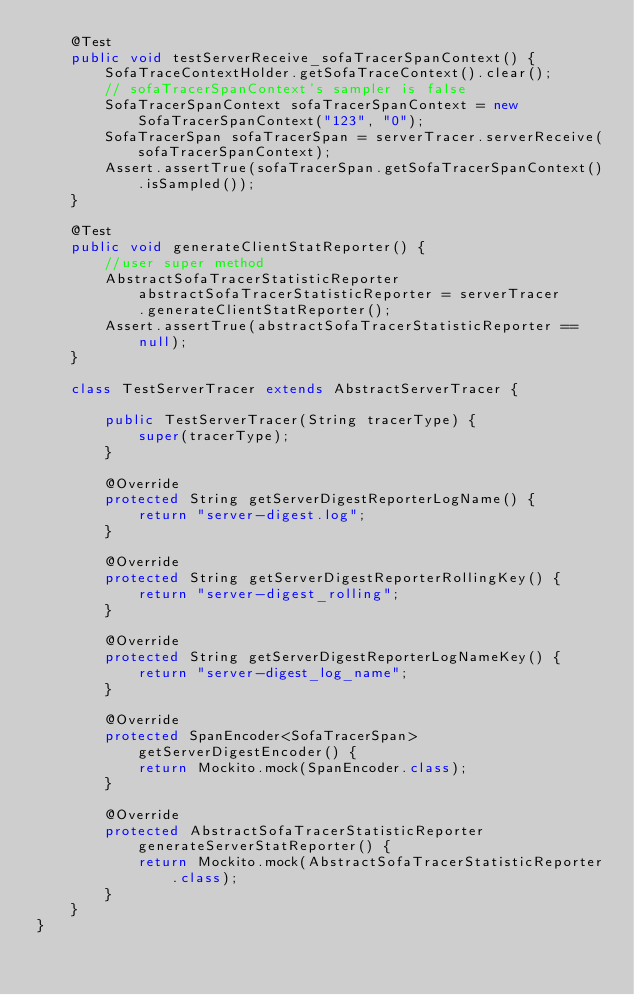Convert code to text. <code><loc_0><loc_0><loc_500><loc_500><_Java_>    @Test
    public void testServerReceive_sofaTracerSpanContext() {
        SofaTraceContextHolder.getSofaTraceContext().clear();
        // sofaTracerSpanContext's sampler is false
        SofaTracerSpanContext sofaTracerSpanContext = new SofaTracerSpanContext("123", "0");
        SofaTracerSpan sofaTracerSpan = serverTracer.serverReceive(sofaTracerSpanContext);
        Assert.assertTrue(sofaTracerSpan.getSofaTracerSpanContext().isSampled());
    }

    @Test
    public void generateClientStatReporter() {
        //user super method
        AbstractSofaTracerStatisticReporter abstractSofaTracerStatisticReporter = serverTracer
            .generateClientStatReporter();
        Assert.assertTrue(abstractSofaTracerStatisticReporter == null);
    }

    class TestServerTracer extends AbstractServerTracer {

        public TestServerTracer(String tracerType) {
            super(tracerType);
        }

        @Override
        protected String getServerDigestReporterLogName() {
            return "server-digest.log";
        }

        @Override
        protected String getServerDigestReporterRollingKey() {
            return "server-digest_rolling";
        }

        @Override
        protected String getServerDigestReporterLogNameKey() {
            return "server-digest_log_name";
        }

        @Override
        protected SpanEncoder<SofaTracerSpan> getServerDigestEncoder() {
            return Mockito.mock(SpanEncoder.class);
        }

        @Override
        protected AbstractSofaTracerStatisticReporter generateServerStatReporter() {
            return Mockito.mock(AbstractSofaTracerStatisticReporter.class);
        }
    }
}</code> 